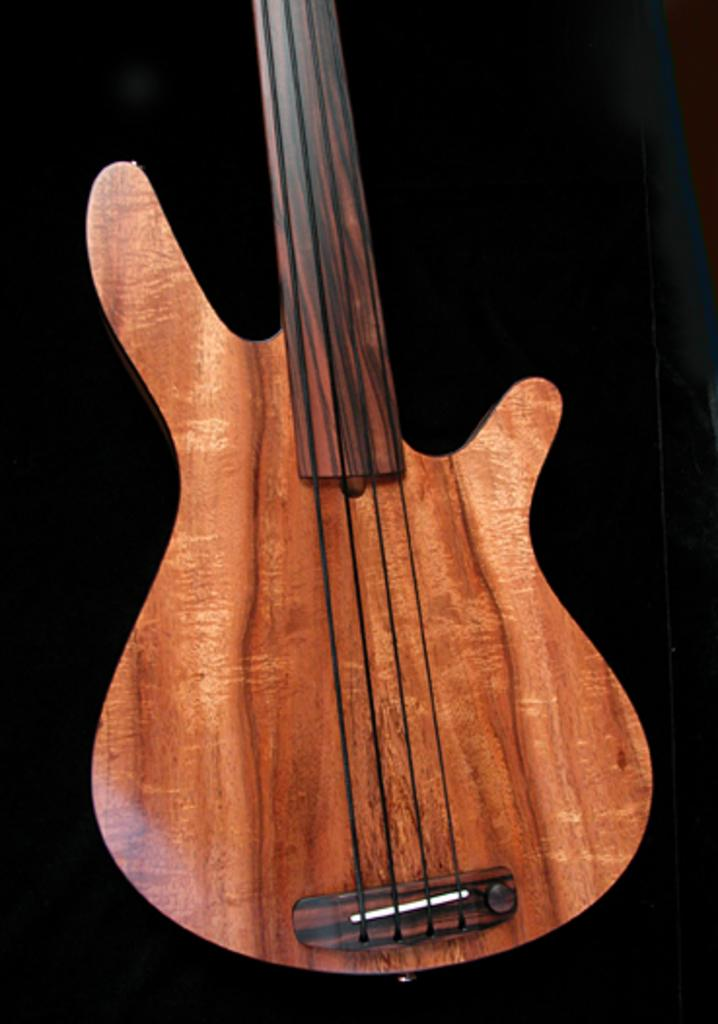What type of musical instrument is present in the image? There is a wooden guitar in the image. What type of drum is being played by the carpenter in the image? There is no drum or carpenter present in the image; it only features a wooden guitar. 